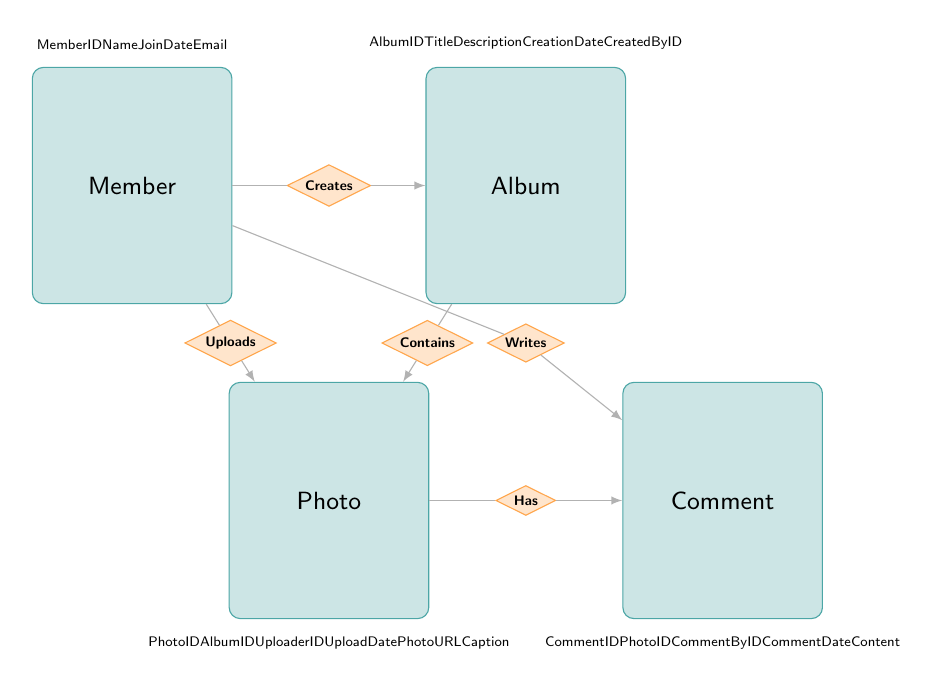What is the relationship between Member and Album? The diagram indicates that there is a "Creates" relationship from Member to Album, which shows how members can create albums in the system.
Answer: Creates How many attributes does the Photo entity have? The Photo entity has six attributes listed, which are PhotoID, AlbumID, UploaderID, UploadDate, PhotoURL, and Caption.
Answer: Six What entity can a Comment belong to? According to the diagram, a Comment is associated with a Photo through the "Has" relationship, meaning each comment relates to a specific photo.
Answer: Photo Which entity uploads photos? The relationship "Uploads" connects the Member entity to Photos, indicating that members are responsible for uploading the photos.
Answer: Member What is the primary key of the Album entity? In the diagram, the Album entity has an attribute called AlbumID, which serves as its primary key for identifying each album uniquely.
Answer: AlbumID If a member writes a comment, what entity do they comment on? The diagram shows that the "Writes" relationship from Member leads to Comment, which in turn has a relationship "Has" with Photo. Thus, each comment written by a member is associated with a specific photo.
Answer: Photo How many relationships are depicted in the diagram? There are five relationships shown in the diagram: Creates, Uploads, Contains, Writes, and Has, indicating various interactions between the entities.
Answer: Five Can a member create multiple albums? Since the relationship "Creates" from Member to Album is not restricted to a single instance, it implies that a member can create multiple albums over time.
Answer: Yes What relationship connects Album and Photo? The relationship labeled "Contains" connects the Album entity to the Photo entity, indicating that albums can contain multiple photos.
Answer: Contains 